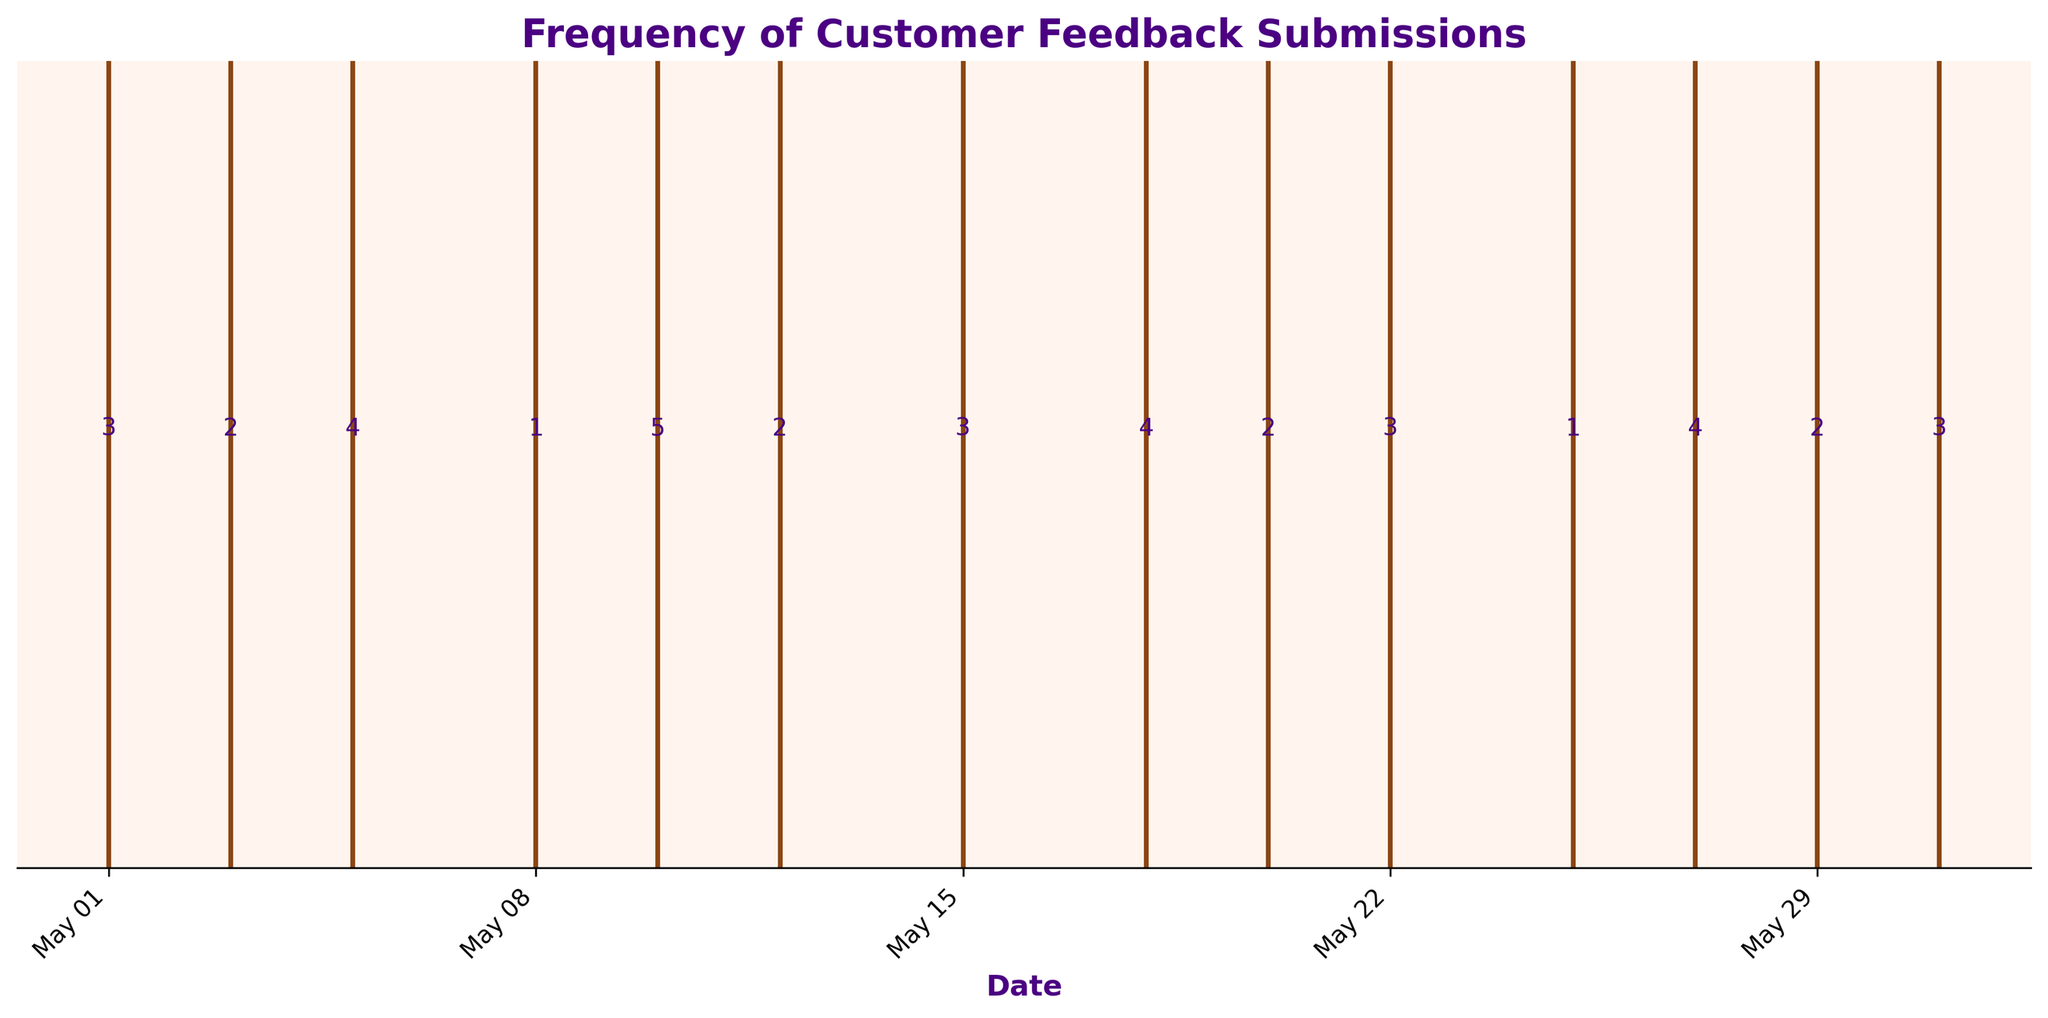What is the main title of the plot? The main title is typically found at the top of the plot. It provides a summary of the figure. In this case, the title is bold and easy to identify.
Answer: Frequency of Customer Feedback Submissions How many feedback submissions were recorded on May 10th? Locate May 10th on the x-axis and look for the annotation directly above the event line. The annotation shows the number of feedback submissions for that date.
Answer: 5 On which date(s) was only one feedback submission recorded? Scan the annotations above the event lines for the number "1" and then check the corresponding date(s) directly below on the x-axis.
Answer: May 8th, May 25th Which date had the highest number of feedback submissions? Look for the highest number above the event lines throughout the plot. Identify the corresponding date directly below that number on the x-axis.
Answer: May 10th Comparing May 3rd and May 20th, which date had more feedback submissions? Find the annotations above the event lines for both dates. Compare the numbers to determine which is larger.
Answer: May 3rd What is the total number of feedback submissions for the month? Add all the feedback counts annotated above the event lines in the plot to find the total. In this case, sum the numbers (3+2+4+1+5+2+3+4+2+3+1+4+2+3).
Answer: 39 How do the feedback counts vary between the first and the last week of the month? Identify the feedback counts for dates within the first and last week. Sum the counts for each period and compare. First week: May 1, May 3, May 5 (3+2+4=9). Last week: May 25, May 27, May 29, May 31 (1+4+2+3=10). Numerically compare the sums.
Answer: First week: 9, Last week: 10 What's the average number of feedback submissions per day in the given data? Calculate the average by dividing the total number of feedback submissions by the number of days. In this case, sum up all counts (39) and divide by the number of dates (14).
Answer: 2.79 Is there a recurring pattern in feedback submissions throughout the month? Examine the event lines and the associated counts over the entire month. Look for any consistent shapes or intervals in the data points. Observing the pattern reveals if submissions cluster around specific dates or are evenly distributed.
Answer: No clear recurring pattern 